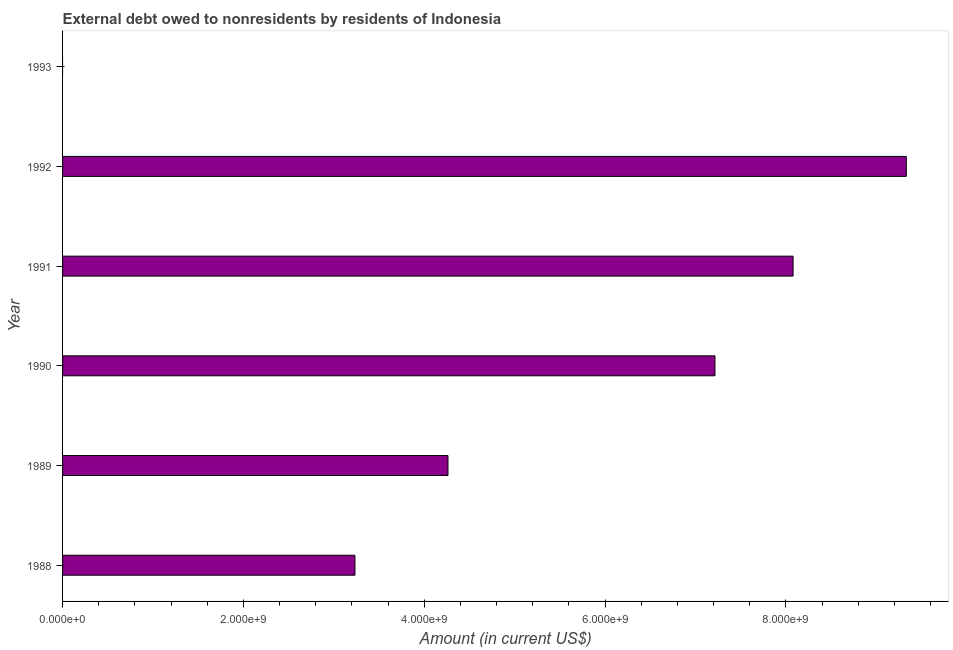Does the graph contain any zero values?
Provide a succinct answer. Yes. Does the graph contain grids?
Provide a succinct answer. No. What is the title of the graph?
Provide a succinct answer. External debt owed to nonresidents by residents of Indonesia. What is the label or title of the X-axis?
Your answer should be very brief. Amount (in current US$). What is the label or title of the Y-axis?
Give a very brief answer. Year. What is the debt in 1991?
Make the answer very short. 8.08e+09. Across all years, what is the maximum debt?
Make the answer very short. 9.33e+09. Across all years, what is the minimum debt?
Give a very brief answer. 0. In which year was the debt maximum?
Keep it short and to the point. 1992. What is the sum of the debt?
Your response must be concise. 3.21e+1. What is the difference between the debt in 1988 and 1989?
Give a very brief answer. -1.03e+09. What is the average debt per year?
Provide a succinct answer. 5.35e+09. What is the median debt?
Provide a succinct answer. 5.74e+09. In how many years, is the debt greater than 2000000000 US$?
Keep it short and to the point. 5. What is the ratio of the debt in 1990 to that in 1992?
Your answer should be compact. 0.77. What is the difference between the highest and the second highest debt?
Make the answer very short. 1.25e+09. What is the difference between the highest and the lowest debt?
Provide a succinct answer. 9.33e+09. In how many years, is the debt greater than the average debt taken over all years?
Make the answer very short. 3. Are all the bars in the graph horizontal?
Provide a succinct answer. Yes. Are the values on the major ticks of X-axis written in scientific E-notation?
Ensure brevity in your answer.  Yes. What is the Amount (in current US$) of 1988?
Your answer should be very brief. 3.23e+09. What is the Amount (in current US$) in 1989?
Ensure brevity in your answer.  4.26e+09. What is the Amount (in current US$) in 1990?
Offer a terse response. 7.22e+09. What is the Amount (in current US$) in 1991?
Offer a very short reply. 8.08e+09. What is the Amount (in current US$) in 1992?
Ensure brevity in your answer.  9.33e+09. What is the difference between the Amount (in current US$) in 1988 and 1989?
Your answer should be very brief. -1.03e+09. What is the difference between the Amount (in current US$) in 1988 and 1990?
Your response must be concise. -3.98e+09. What is the difference between the Amount (in current US$) in 1988 and 1991?
Make the answer very short. -4.85e+09. What is the difference between the Amount (in current US$) in 1988 and 1992?
Your answer should be compact. -6.10e+09. What is the difference between the Amount (in current US$) in 1989 and 1990?
Provide a succinct answer. -2.95e+09. What is the difference between the Amount (in current US$) in 1989 and 1991?
Keep it short and to the point. -3.82e+09. What is the difference between the Amount (in current US$) in 1989 and 1992?
Your answer should be very brief. -5.07e+09. What is the difference between the Amount (in current US$) in 1990 and 1991?
Provide a succinct answer. -8.64e+08. What is the difference between the Amount (in current US$) in 1990 and 1992?
Make the answer very short. -2.12e+09. What is the difference between the Amount (in current US$) in 1991 and 1992?
Your response must be concise. -1.25e+09. What is the ratio of the Amount (in current US$) in 1988 to that in 1989?
Provide a succinct answer. 0.76. What is the ratio of the Amount (in current US$) in 1988 to that in 1990?
Give a very brief answer. 0.45. What is the ratio of the Amount (in current US$) in 1988 to that in 1992?
Keep it short and to the point. 0.35. What is the ratio of the Amount (in current US$) in 1989 to that in 1990?
Ensure brevity in your answer.  0.59. What is the ratio of the Amount (in current US$) in 1989 to that in 1991?
Provide a short and direct response. 0.53. What is the ratio of the Amount (in current US$) in 1989 to that in 1992?
Provide a succinct answer. 0.46. What is the ratio of the Amount (in current US$) in 1990 to that in 1991?
Your answer should be compact. 0.89. What is the ratio of the Amount (in current US$) in 1990 to that in 1992?
Provide a short and direct response. 0.77. What is the ratio of the Amount (in current US$) in 1991 to that in 1992?
Offer a terse response. 0.87. 